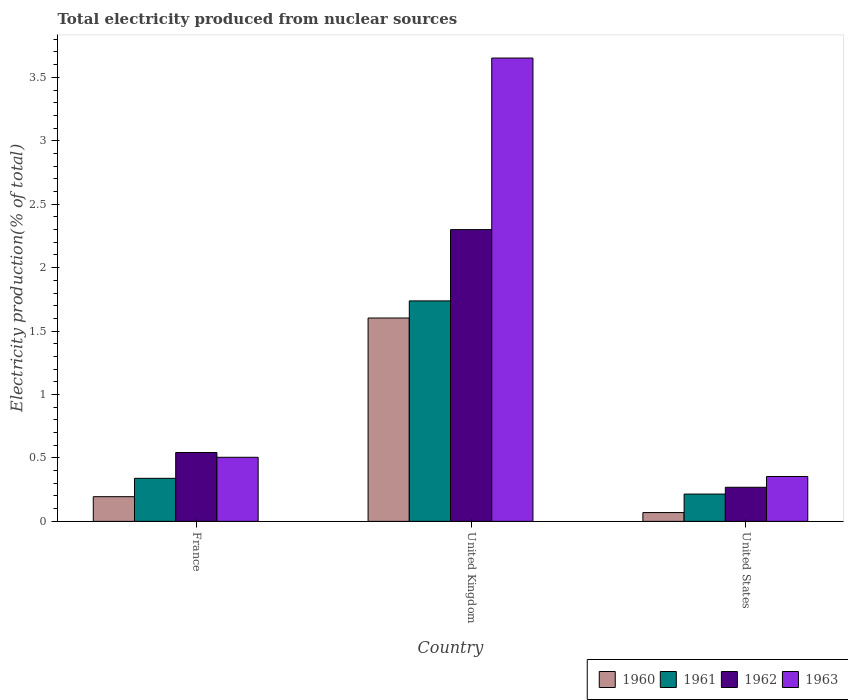Are the number of bars per tick equal to the number of legend labels?
Make the answer very short. Yes. Are the number of bars on each tick of the X-axis equal?
Your response must be concise. Yes. How many bars are there on the 2nd tick from the left?
Offer a terse response. 4. How many bars are there on the 3rd tick from the right?
Keep it short and to the point. 4. What is the label of the 2nd group of bars from the left?
Give a very brief answer. United Kingdom. What is the total electricity produced in 1961 in France?
Offer a very short reply. 0.34. Across all countries, what is the maximum total electricity produced in 1963?
Give a very brief answer. 3.65. Across all countries, what is the minimum total electricity produced in 1960?
Ensure brevity in your answer.  0.07. In which country was the total electricity produced in 1960 maximum?
Your answer should be very brief. United Kingdom. In which country was the total electricity produced in 1962 minimum?
Ensure brevity in your answer.  United States. What is the total total electricity produced in 1962 in the graph?
Offer a terse response. 3.11. What is the difference between the total electricity produced in 1960 in United Kingdom and that in United States?
Give a very brief answer. 1.53. What is the difference between the total electricity produced in 1961 in France and the total electricity produced in 1960 in United Kingdom?
Give a very brief answer. -1.26. What is the average total electricity produced in 1960 per country?
Offer a very short reply. 0.62. What is the difference between the total electricity produced of/in 1963 and total electricity produced of/in 1961 in United States?
Your response must be concise. 0.14. What is the ratio of the total electricity produced in 1962 in France to that in United States?
Provide a succinct answer. 2.02. Is the total electricity produced in 1961 in France less than that in United States?
Make the answer very short. No. Is the difference between the total electricity produced in 1963 in France and United States greater than the difference between the total electricity produced in 1961 in France and United States?
Provide a succinct answer. Yes. What is the difference between the highest and the second highest total electricity produced in 1961?
Make the answer very short. -1.4. What is the difference between the highest and the lowest total electricity produced in 1962?
Keep it short and to the point. 2.03. Is the sum of the total electricity produced in 1961 in France and United States greater than the maximum total electricity produced in 1962 across all countries?
Give a very brief answer. No. What does the 2nd bar from the left in United Kingdom represents?
Provide a succinct answer. 1961. What is the difference between two consecutive major ticks on the Y-axis?
Offer a very short reply. 0.5. Are the values on the major ticks of Y-axis written in scientific E-notation?
Offer a very short reply. No. Does the graph contain any zero values?
Your response must be concise. No. Does the graph contain grids?
Ensure brevity in your answer.  No. Where does the legend appear in the graph?
Keep it short and to the point. Bottom right. How many legend labels are there?
Your answer should be very brief. 4. What is the title of the graph?
Offer a terse response. Total electricity produced from nuclear sources. Does "1978" appear as one of the legend labels in the graph?
Ensure brevity in your answer.  No. What is the label or title of the X-axis?
Your answer should be compact. Country. What is the Electricity production(% of total) of 1960 in France?
Your answer should be compact. 0.19. What is the Electricity production(% of total) in 1961 in France?
Your response must be concise. 0.34. What is the Electricity production(% of total) in 1962 in France?
Ensure brevity in your answer.  0.54. What is the Electricity production(% of total) in 1963 in France?
Provide a succinct answer. 0.51. What is the Electricity production(% of total) in 1960 in United Kingdom?
Your answer should be very brief. 1.6. What is the Electricity production(% of total) in 1961 in United Kingdom?
Offer a terse response. 1.74. What is the Electricity production(% of total) in 1962 in United Kingdom?
Give a very brief answer. 2.3. What is the Electricity production(% of total) of 1963 in United Kingdom?
Provide a short and direct response. 3.65. What is the Electricity production(% of total) of 1960 in United States?
Your answer should be compact. 0.07. What is the Electricity production(% of total) of 1961 in United States?
Offer a terse response. 0.22. What is the Electricity production(% of total) in 1962 in United States?
Your answer should be very brief. 0.27. What is the Electricity production(% of total) in 1963 in United States?
Your answer should be compact. 0.35. Across all countries, what is the maximum Electricity production(% of total) in 1960?
Provide a succinct answer. 1.6. Across all countries, what is the maximum Electricity production(% of total) in 1961?
Give a very brief answer. 1.74. Across all countries, what is the maximum Electricity production(% of total) of 1962?
Your response must be concise. 2.3. Across all countries, what is the maximum Electricity production(% of total) in 1963?
Make the answer very short. 3.65. Across all countries, what is the minimum Electricity production(% of total) of 1960?
Ensure brevity in your answer.  0.07. Across all countries, what is the minimum Electricity production(% of total) in 1961?
Give a very brief answer. 0.22. Across all countries, what is the minimum Electricity production(% of total) of 1962?
Offer a very short reply. 0.27. Across all countries, what is the minimum Electricity production(% of total) of 1963?
Give a very brief answer. 0.35. What is the total Electricity production(% of total) in 1960 in the graph?
Your answer should be compact. 1.87. What is the total Electricity production(% of total) of 1961 in the graph?
Your answer should be compact. 2.29. What is the total Electricity production(% of total) in 1962 in the graph?
Your answer should be very brief. 3.11. What is the total Electricity production(% of total) in 1963 in the graph?
Provide a short and direct response. 4.51. What is the difference between the Electricity production(% of total) in 1960 in France and that in United Kingdom?
Offer a very short reply. -1.41. What is the difference between the Electricity production(% of total) of 1961 in France and that in United Kingdom?
Provide a succinct answer. -1.4. What is the difference between the Electricity production(% of total) of 1962 in France and that in United Kingdom?
Your answer should be compact. -1.76. What is the difference between the Electricity production(% of total) of 1963 in France and that in United Kingdom?
Give a very brief answer. -3.15. What is the difference between the Electricity production(% of total) of 1960 in France and that in United States?
Your response must be concise. 0.13. What is the difference between the Electricity production(% of total) of 1961 in France and that in United States?
Offer a terse response. 0.12. What is the difference between the Electricity production(% of total) in 1962 in France and that in United States?
Provide a succinct answer. 0.27. What is the difference between the Electricity production(% of total) in 1963 in France and that in United States?
Keep it short and to the point. 0.15. What is the difference between the Electricity production(% of total) in 1960 in United Kingdom and that in United States?
Your answer should be very brief. 1.53. What is the difference between the Electricity production(% of total) of 1961 in United Kingdom and that in United States?
Your answer should be very brief. 1.52. What is the difference between the Electricity production(% of total) of 1962 in United Kingdom and that in United States?
Your response must be concise. 2.03. What is the difference between the Electricity production(% of total) of 1963 in United Kingdom and that in United States?
Make the answer very short. 3.3. What is the difference between the Electricity production(% of total) of 1960 in France and the Electricity production(% of total) of 1961 in United Kingdom?
Give a very brief answer. -1.54. What is the difference between the Electricity production(% of total) of 1960 in France and the Electricity production(% of total) of 1962 in United Kingdom?
Your response must be concise. -2.11. What is the difference between the Electricity production(% of total) in 1960 in France and the Electricity production(% of total) in 1963 in United Kingdom?
Provide a short and direct response. -3.46. What is the difference between the Electricity production(% of total) in 1961 in France and the Electricity production(% of total) in 1962 in United Kingdom?
Ensure brevity in your answer.  -1.96. What is the difference between the Electricity production(% of total) of 1961 in France and the Electricity production(% of total) of 1963 in United Kingdom?
Provide a succinct answer. -3.31. What is the difference between the Electricity production(% of total) of 1962 in France and the Electricity production(% of total) of 1963 in United Kingdom?
Offer a very short reply. -3.11. What is the difference between the Electricity production(% of total) of 1960 in France and the Electricity production(% of total) of 1961 in United States?
Offer a terse response. -0.02. What is the difference between the Electricity production(% of total) of 1960 in France and the Electricity production(% of total) of 1962 in United States?
Your response must be concise. -0.07. What is the difference between the Electricity production(% of total) of 1960 in France and the Electricity production(% of total) of 1963 in United States?
Make the answer very short. -0.16. What is the difference between the Electricity production(% of total) of 1961 in France and the Electricity production(% of total) of 1962 in United States?
Ensure brevity in your answer.  0.07. What is the difference between the Electricity production(% of total) in 1961 in France and the Electricity production(% of total) in 1963 in United States?
Your answer should be very brief. -0.01. What is the difference between the Electricity production(% of total) of 1962 in France and the Electricity production(% of total) of 1963 in United States?
Give a very brief answer. 0.19. What is the difference between the Electricity production(% of total) in 1960 in United Kingdom and the Electricity production(% of total) in 1961 in United States?
Offer a very short reply. 1.39. What is the difference between the Electricity production(% of total) of 1960 in United Kingdom and the Electricity production(% of total) of 1962 in United States?
Offer a terse response. 1.33. What is the difference between the Electricity production(% of total) in 1960 in United Kingdom and the Electricity production(% of total) in 1963 in United States?
Offer a terse response. 1.25. What is the difference between the Electricity production(% of total) of 1961 in United Kingdom and the Electricity production(% of total) of 1962 in United States?
Give a very brief answer. 1.47. What is the difference between the Electricity production(% of total) in 1961 in United Kingdom and the Electricity production(% of total) in 1963 in United States?
Ensure brevity in your answer.  1.38. What is the difference between the Electricity production(% of total) of 1962 in United Kingdom and the Electricity production(% of total) of 1963 in United States?
Make the answer very short. 1.95. What is the average Electricity production(% of total) of 1960 per country?
Provide a short and direct response. 0.62. What is the average Electricity production(% of total) of 1961 per country?
Offer a terse response. 0.76. What is the average Electricity production(% of total) in 1963 per country?
Make the answer very short. 1.5. What is the difference between the Electricity production(% of total) of 1960 and Electricity production(% of total) of 1961 in France?
Offer a very short reply. -0.14. What is the difference between the Electricity production(% of total) in 1960 and Electricity production(% of total) in 1962 in France?
Keep it short and to the point. -0.35. What is the difference between the Electricity production(% of total) in 1960 and Electricity production(% of total) in 1963 in France?
Offer a very short reply. -0.31. What is the difference between the Electricity production(% of total) in 1961 and Electricity production(% of total) in 1962 in France?
Provide a succinct answer. -0.2. What is the difference between the Electricity production(% of total) of 1961 and Electricity production(% of total) of 1963 in France?
Ensure brevity in your answer.  -0.17. What is the difference between the Electricity production(% of total) of 1962 and Electricity production(% of total) of 1963 in France?
Offer a very short reply. 0.04. What is the difference between the Electricity production(% of total) in 1960 and Electricity production(% of total) in 1961 in United Kingdom?
Ensure brevity in your answer.  -0.13. What is the difference between the Electricity production(% of total) of 1960 and Electricity production(% of total) of 1962 in United Kingdom?
Give a very brief answer. -0.7. What is the difference between the Electricity production(% of total) of 1960 and Electricity production(% of total) of 1963 in United Kingdom?
Provide a succinct answer. -2.05. What is the difference between the Electricity production(% of total) in 1961 and Electricity production(% of total) in 1962 in United Kingdom?
Offer a very short reply. -0.56. What is the difference between the Electricity production(% of total) of 1961 and Electricity production(% of total) of 1963 in United Kingdom?
Make the answer very short. -1.91. What is the difference between the Electricity production(% of total) in 1962 and Electricity production(% of total) in 1963 in United Kingdom?
Offer a terse response. -1.35. What is the difference between the Electricity production(% of total) in 1960 and Electricity production(% of total) in 1961 in United States?
Offer a terse response. -0.15. What is the difference between the Electricity production(% of total) of 1960 and Electricity production(% of total) of 1962 in United States?
Keep it short and to the point. -0.2. What is the difference between the Electricity production(% of total) in 1960 and Electricity production(% of total) in 1963 in United States?
Give a very brief answer. -0.28. What is the difference between the Electricity production(% of total) of 1961 and Electricity production(% of total) of 1962 in United States?
Provide a succinct answer. -0.05. What is the difference between the Electricity production(% of total) of 1961 and Electricity production(% of total) of 1963 in United States?
Ensure brevity in your answer.  -0.14. What is the difference between the Electricity production(% of total) of 1962 and Electricity production(% of total) of 1963 in United States?
Your response must be concise. -0.09. What is the ratio of the Electricity production(% of total) of 1960 in France to that in United Kingdom?
Make the answer very short. 0.12. What is the ratio of the Electricity production(% of total) in 1961 in France to that in United Kingdom?
Provide a short and direct response. 0.2. What is the ratio of the Electricity production(% of total) in 1962 in France to that in United Kingdom?
Provide a short and direct response. 0.24. What is the ratio of the Electricity production(% of total) in 1963 in France to that in United Kingdom?
Keep it short and to the point. 0.14. What is the ratio of the Electricity production(% of total) in 1960 in France to that in United States?
Your answer should be very brief. 2.81. What is the ratio of the Electricity production(% of total) of 1961 in France to that in United States?
Make the answer very short. 1.58. What is the ratio of the Electricity production(% of total) in 1962 in France to that in United States?
Offer a very short reply. 2.02. What is the ratio of the Electricity production(% of total) of 1963 in France to that in United States?
Offer a terse response. 1.43. What is the ratio of the Electricity production(% of total) in 1960 in United Kingdom to that in United States?
Your answer should be compact. 23.14. What is the ratio of the Electricity production(% of total) in 1961 in United Kingdom to that in United States?
Ensure brevity in your answer.  8.08. What is the ratio of the Electricity production(% of total) of 1962 in United Kingdom to that in United States?
Provide a succinct answer. 8.56. What is the ratio of the Electricity production(% of total) of 1963 in United Kingdom to that in United States?
Provide a short and direct response. 10.32. What is the difference between the highest and the second highest Electricity production(% of total) in 1960?
Your response must be concise. 1.41. What is the difference between the highest and the second highest Electricity production(% of total) in 1961?
Ensure brevity in your answer.  1.4. What is the difference between the highest and the second highest Electricity production(% of total) of 1962?
Give a very brief answer. 1.76. What is the difference between the highest and the second highest Electricity production(% of total) of 1963?
Offer a terse response. 3.15. What is the difference between the highest and the lowest Electricity production(% of total) of 1960?
Your response must be concise. 1.53. What is the difference between the highest and the lowest Electricity production(% of total) of 1961?
Your answer should be compact. 1.52. What is the difference between the highest and the lowest Electricity production(% of total) in 1962?
Provide a succinct answer. 2.03. What is the difference between the highest and the lowest Electricity production(% of total) of 1963?
Your answer should be compact. 3.3. 